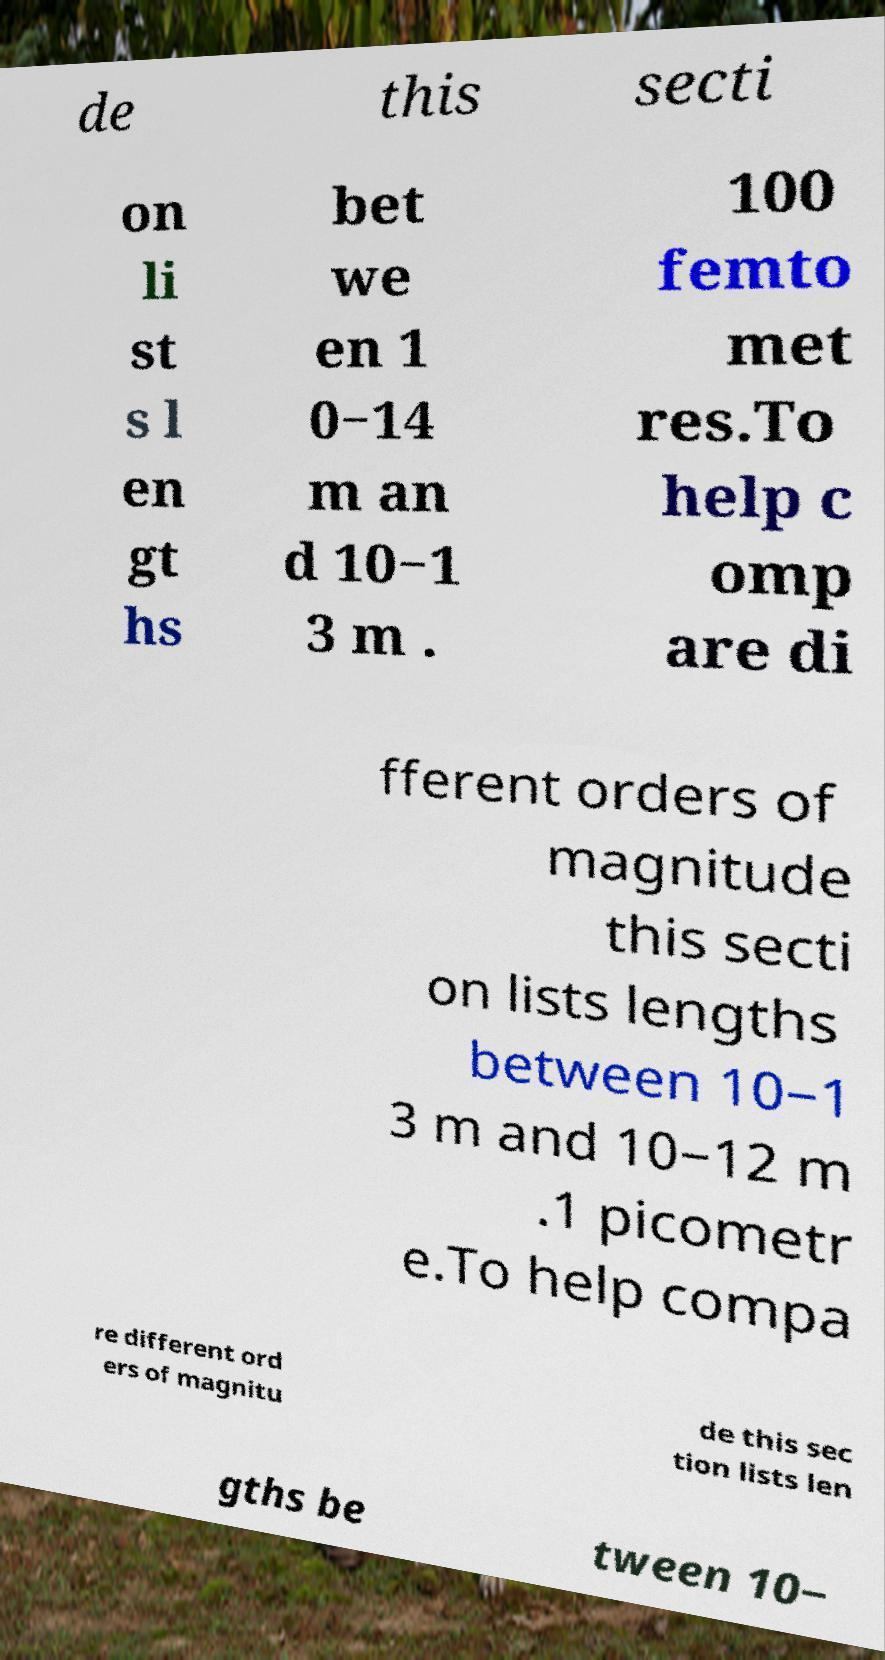I need the written content from this picture converted into text. Can you do that? de this secti on li st s l en gt hs bet we en 1 0−14 m an d 10−1 3 m . 100 femto met res.To help c omp are di fferent orders of magnitude this secti on lists lengths between 10−1 3 m and 10−12 m .1 picometr e.To help compa re different ord ers of magnitu de this sec tion lists len gths be tween 10− 